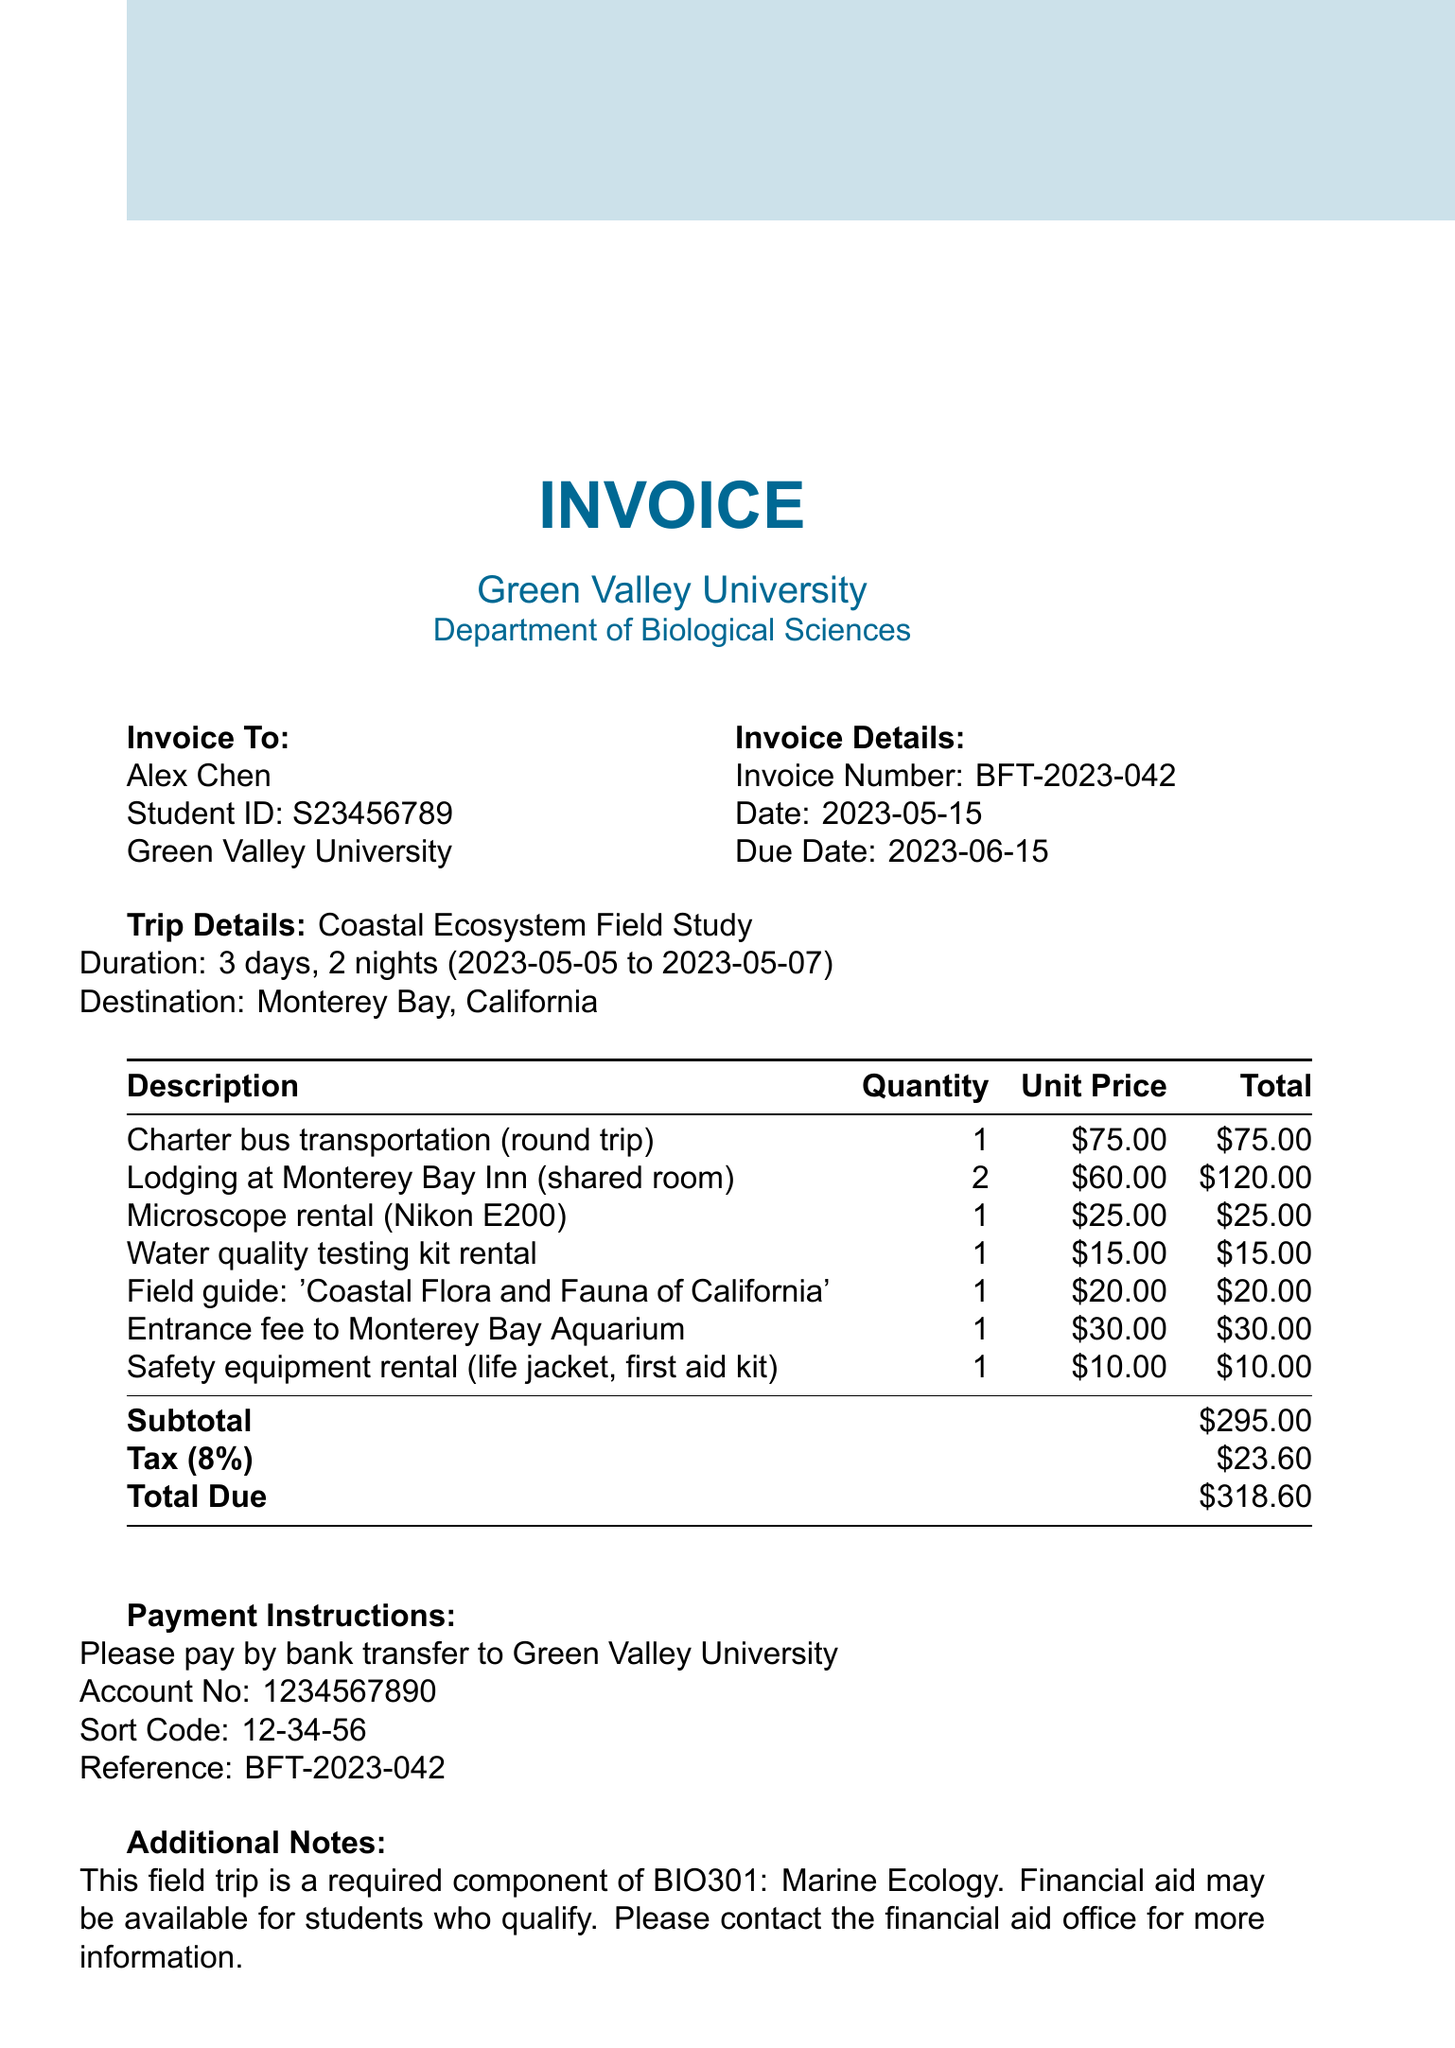What is the invoice number? The invoice number is a unique identifier for the transaction, listed directly in the document.
Answer: BFT-2023-042 What are the trip dates? The trip dates encompass the duration of the field study, which is clearly stated in the document.
Answer: 2023-05-05 to 2023-05-07 How much is the total due? The total due is the final amount that needs to be paid, derived from the subtotal and tax present in the document.
Answer: $318.60 What is the quantity of microscope rentals? The quantity of microscope rentals is specified in the line items of the invoice.
Answer: 1 Which department is organizing the field trip? The organizing department is identified in the header information of the invoice.
Answer: Department of Biological Sciences What is the duration of the trip? The duration of the trip indicates how long the field study will last, as mentioned in the document.
Answer: 3 days, 2 nights What is the tax rate applied? The tax rate is provided in the invoice, detailing the percentage applied to the subtotal.
Answer: 8% What type of lodging is included? The lodging type specifies the accommodation arrangement during the trip, as mentioned in the itemized expenses.
Answer: shared room What is mentioned about financial aid? The document notes availability related to financial support for eligible students.
Answer: Financial aid may be available for students who qualify 